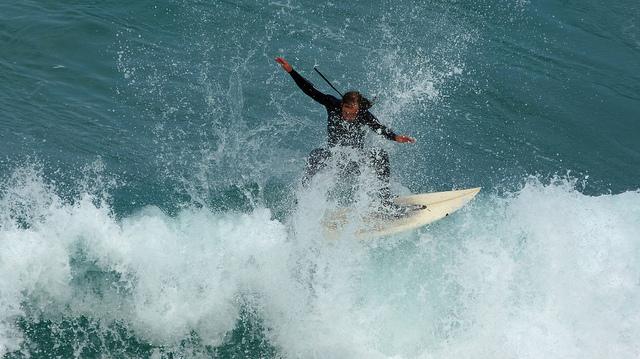What color board is he on?
Concise answer only. White. Are they surfing on a longboard?
Write a very short answer. Yes. What is the person wearing?
Write a very short answer. Wetsuit. 